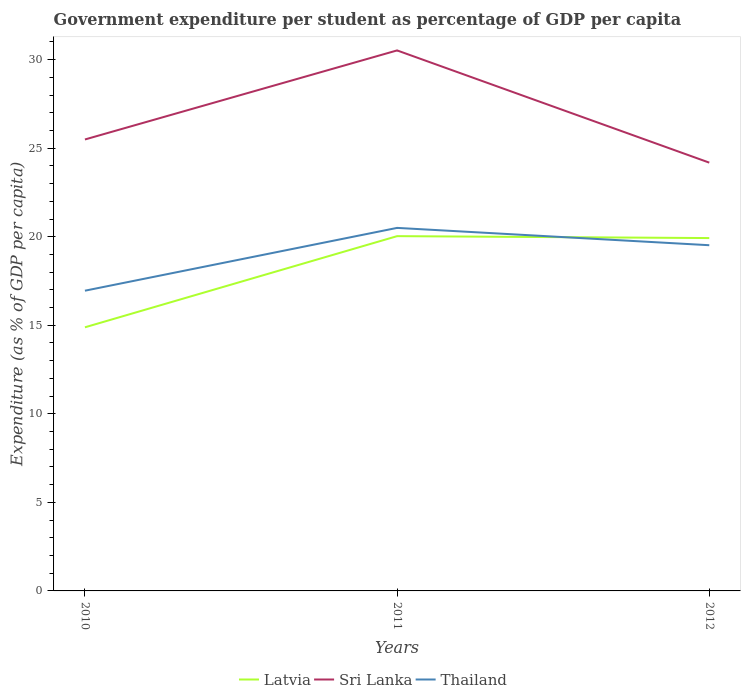How many different coloured lines are there?
Your answer should be compact. 3. Does the line corresponding to Thailand intersect with the line corresponding to Sri Lanka?
Your answer should be very brief. No. Across all years, what is the maximum percentage of expenditure per student in Thailand?
Your answer should be very brief. 16.95. What is the total percentage of expenditure per student in Thailand in the graph?
Keep it short and to the point. -2.57. What is the difference between the highest and the second highest percentage of expenditure per student in Latvia?
Your answer should be compact. 5.15. Is the percentage of expenditure per student in Latvia strictly greater than the percentage of expenditure per student in Sri Lanka over the years?
Offer a very short reply. Yes. How many lines are there?
Ensure brevity in your answer.  3. How many years are there in the graph?
Make the answer very short. 3. What is the difference between two consecutive major ticks on the Y-axis?
Ensure brevity in your answer.  5. Does the graph contain any zero values?
Keep it short and to the point. No. Does the graph contain grids?
Keep it short and to the point. No. What is the title of the graph?
Keep it short and to the point. Government expenditure per student as percentage of GDP per capita. Does "St. Lucia" appear as one of the legend labels in the graph?
Give a very brief answer. No. What is the label or title of the X-axis?
Provide a succinct answer. Years. What is the label or title of the Y-axis?
Make the answer very short. Expenditure (as % of GDP per capita). What is the Expenditure (as % of GDP per capita) in Latvia in 2010?
Offer a terse response. 14.89. What is the Expenditure (as % of GDP per capita) in Sri Lanka in 2010?
Keep it short and to the point. 25.49. What is the Expenditure (as % of GDP per capita) of Thailand in 2010?
Your response must be concise. 16.95. What is the Expenditure (as % of GDP per capita) in Latvia in 2011?
Your answer should be very brief. 20.03. What is the Expenditure (as % of GDP per capita) of Sri Lanka in 2011?
Ensure brevity in your answer.  30.52. What is the Expenditure (as % of GDP per capita) in Thailand in 2011?
Your response must be concise. 20.5. What is the Expenditure (as % of GDP per capita) of Latvia in 2012?
Ensure brevity in your answer.  19.93. What is the Expenditure (as % of GDP per capita) in Sri Lanka in 2012?
Your response must be concise. 24.19. What is the Expenditure (as % of GDP per capita) of Thailand in 2012?
Provide a succinct answer. 19.52. Across all years, what is the maximum Expenditure (as % of GDP per capita) in Latvia?
Give a very brief answer. 20.03. Across all years, what is the maximum Expenditure (as % of GDP per capita) of Sri Lanka?
Make the answer very short. 30.52. Across all years, what is the maximum Expenditure (as % of GDP per capita) in Thailand?
Your response must be concise. 20.5. Across all years, what is the minimum Expenditure (as % of GDP per capita) in Latvia?
Your answer should be very brief. 14.89. Across all years, what is the minimum Expenditure (as % of GDP per capita) in Sri Lanka?
Offer a terse response. 24.19. Across all years, what is the minimum Expenditure (as % of GDP per capita) of Thailand?
Keep it short and to the point. 16.95. What is the total Expenditure (as % of GDP per capita) in Latvia in the graph?
Your response must be concise. 54.85. What is the total Expenditure (as % of GDP per capita) of Sri Lanka in the graph?
Make the answer very short. 80.2. What is the total Expenditure (as % of GDP per capita) of Thailand in the graph?
Your response must be concise. 56.98. What is the difference between the Expenditure (as % of GDP per capita) of Latvia in 2010 and that in 2011?
Offer a terse response. -5.15. What is the difference between the Expenditure (as % of GDP per capita) of Sri Lanka in 2010 and that in 2011?
Make the answer very short. -5.03. What is the difference between the Expenditure (as % of GDP per capita) of Thailand in 2010 and that in 2011?
Ensure brevity in your answer.  -3.55. What is the difference between the Expenditure (as % of GDP per capita) of Latvia in 2010 and that in 2012?
Your response must be concise. -5.04. What is the difference between the Expenditure (as % of GDP per capita) of Sri Lanka in 2010 and that in 2012?
Make the answer very short. 1.31. What is the difference between the Expenditure (as % of GDP per capita) of Thailand in 2010 and that in 2012?
Your answer should be compact. -2.57. What is the difference between the Expenditure (as % of GDP per capita) of Latvia in 2011 and that in 2012?
Your answer should be compact. 0.11. What is the difference between the Expenditure (as % of GDP per capita) in Sri Lanka in 2011 and that in 2012?
Your answer should be compact. 6.34. What is the difference between the Expenditure (as % of GDP per capita) in Thailand in 2011 and that in 2012?
Offer a very short reply. 0.98. What is the difference between the Expenditure (as % of GDP per capita) of Latvia in 2010 and the Expenditure (as % of GDP per capita) of Sri Lanka in 2011?
Your response must be concise. -15.64. What is the difference between the Expenditure (as % of GDP per capita) in Latvia in 2010 and the Expenditure (as % of GDP per capita) in Thailand in 2011?
Your answer should be very brief. -5.61. What is the difference between the Expenditure (as % of GDP per capita) of Sri Lanka in 2010 and the Expenditure (as % of GDP per capita) of Thailand in 2011?
Your answer should be very brief. 4.99. What is the difference between the Expenditure (as % of GDP per capita) in Latvia in 2010 and the Expenditure (as % of GDP per capita) in Sri Lanka in 2012?
Provide a short and direct response. -9.3. What is the difference between the Expenditure (as % of GDP per capita) in Latvia in 2010 and the Expenditure (as % of GDP per capita) in Thailand in 2012?
Keep it short and to the point. -4.64. What is the difference between the Expenditure (as % of GDP per capita) of Sri Lanka in 2010 and the Expenditure (as % of GDP per capita) of Thailand in 2012?
Provide a succinct answer. 5.97. What is the difference between the Expenditure (as % of GDP per capita) of Latvia in 2011 and the Expenditure (as % of GDP per capita) of Sri Lanka in 2012?
Offer a terse response. -4.15. What is the difference between the Expenditure (as % of GDP per capita) in Latvia in 2011 and the Expenditure (as % of GDP per capita) in Thailand in 2012?
Provide a succinct answer. 0.51. What is the difference between the Expenditure (as % of GDP per capita) of Sri Lanka in 2011 and the Expenditure (as % of GDP per capita) of Thailand in 2012?
Ensure brevity in your answer.  11. What is the average Expenditure (as % of GDP per capita) of Latvia per year?
Give a very brief answer. 18.28. What is the average Expenditure (as % of GDP per capita) in Sri Lanka per year?
Offer a terse response. 26.73. What is the average Expenditure (as % of GDP per capita) in Thailand per year?
Provide a short and direct response. 18.99. In the year 2010, what is the difference between the Expenditure (as % of GDP per capita) in Latvia and Expenditure (as % of GDP per capita) in Sri Lanka?
Offer a very short reply. -10.61. In the year 2010, what is the difference between the Expenditure (as % of GDP per capita) in Latvia and Expenditure (as % of GDP per capita) in Thailand?
Provide a succinct answer. -2.07. In the year 2010, what is the difference between the Expenditure (as % of GDP per capita) of Sri Lanka and Expenditure (as % of GDP per capita) of Thailand?
Give a very brief answer. 8.54. In the year 2011, what is the difference between the Expenditure (as % of GDP per capita) in Latvia and Expenditure (as % of GDP per capita) in Sri Lanka?
Offer a terse response. -10.49. In the year 2011, what is the difference between the Expenditure (as % of GDP per capita) of Latvia and Expenditure (as % of GDP per capita) of Thailand?
Provide a short and direct response. -0.47. In the year 2011, what is the difference between the Expenditure (as % of GDP per capita) of Sri Lanka and Expenditure (as % of GDP per capita) of Thailand?
Make the answer very short. 10.02. In the year 2012, what is the difference between the Expenditure (as % of GDP per capita) in Latvia and Expenditure (as % of GDP per capita) in Sri Lanka?
Your response must be concise. -4.26. In the year 2012, what is the difference between the Expenditure (as % of GDP per capita) of Latvia and Expenditure (as % of GDP per capita) of Thailand?
Give a very brief answer. 0.4. In the year 2012, what is the difference between the Expenditure (as % of GDP per capita) in Sri Lanka and Expenditure (as % of GDP per capita) in Thailand?
Offer a very short reply. 4.66. What is the ratio of the Expenditure (as % of GDP per capita) of Latvia in 2010 to that in 2011?
Provide a short and direct response. 0.74. What is the ratio of the Expenditure (as % of GDP per capita) of Sri Lanka in 2010 to that in 2011?
Offer a terse response. 0.84. What is the ratio of the Expenditure (as % of GDP per capita) in Thailand in 2010 to that in 2011?
Offer a very short reply. 0.83. What is the ratio of the Expenditure (as % of GDP per capita) in Latvia in 2010 to that in 2012?
Keep it short and to the point. 0.75. What is the ratio of the Expenditure (as % of GDP per capita) in Sri Lanka in 2010 to that in 2012?
Your response must be concise. 1.05. What is the ratio of the Expenditure (as % of GDP per capita) of Thailand in 2010 to that in 2012?
Offer a very short reply. 0.87. What is the ratio of the Expenditure (as % of GDP per capita) of Sri Lanka in 2011 to that in 2012?
Give a very brief answer. 1.26. What is the ratio of the Expenditure (as % of GDP per capita) in Thailand in 2011 to that in 2012?
Provide a short and direct response. 1.05. What is the difference between the highest and the second highest Expenditure (as % of GDP per capita) in Latvia?
Your answer should be compact. 0.11. What is the difference between the highest and the second highest Expenditure (as % of GDP per capita) in Sri Lanka?
Your response must be concise. 5.03. What is the difference between the highest and the lowest Expenditure (as % of GDP per capita) in Latvia?
Ensure brevity in your answer.  5.15. What is the difference between the highest and the lowest Expenditure (as % of GDP per capita) in Sri Lanka?
Make the answer very short. 6.34. What is the difference between the highest and the lowest Expenditure (as % of GDP per capita) of Thailand?
Make the answer very short. 3.55. 